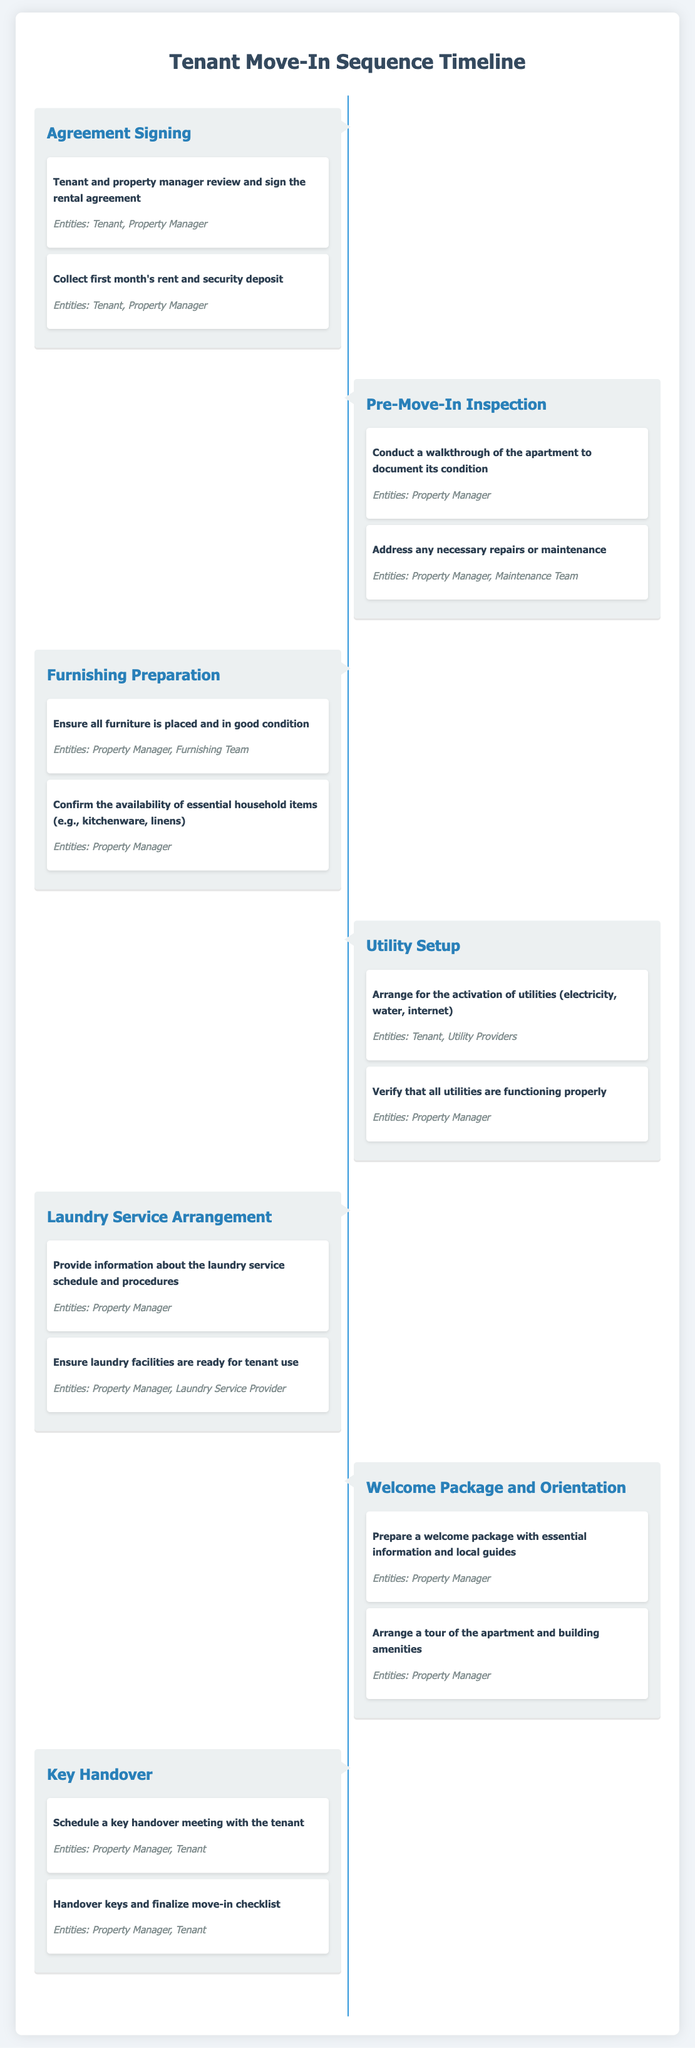What is the first step in the Tenant Move-In Sequence? The first step listed in the sequence is "Agreement Signing."
Answer: Agreement Signing How many entities are involved in the "Agreement Signing" step? The "Agreement Signing" step mentions two entities: Tenant and Property Manager.
Answer: 2 What is verified in the "Utility Setup" step? The "Utility Setup" step involves verifying that all utilities are functioning properly.
Answer: All utilities functioning properly What is included in the welcome package mentioned in the "Welcome Package and Orientation"? The welcome package includes essential information and local guides.
Answer: Essential information and local guides Who is responsible for ensuring that laundry facilities are ready for tenant use? The "Laundry Service Arrangement" step mentions both the Property Manager and Laundry Service Provider for this responsibility.
Answer: Property Manager, Laundry Service Provider What does the "Pre-Move-In Inspection" involve? The "Pre-Move-In Inspection" includes conducting a walkthrough and addressing necessary repairs or maintenance.
Answer: Walkthrough and addressing repairs How many milestones are there in the "Key Handover" step? The "Key Handover" step contains two milestones related to scheduling a meeting and handing over keys.
Answer: 2 What should the Tenant do regarding utilities before moving in? The Tenant is responsible for arranging the activation of utilities in the "Utility Setup" step.
Answer: Arrange activation of utilities When is the key handover meeting scheduled? The "Key Handover" step mentions scheduling a key handover meeting with the tenant.
Answer: Key handover meeting 